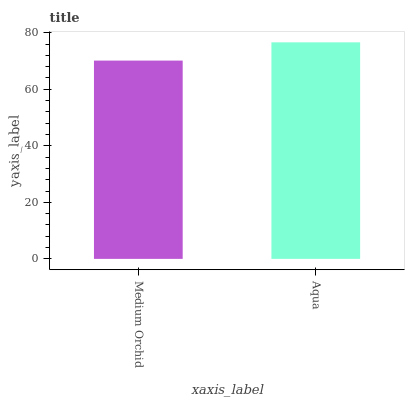Is Aqua the minimum?
Answer yes or no. No. Is Aqua greater than Medium Orchid?
Answer yes or no. Yes. Is Medium Orchid less than Aqua?
Answer yes or no. Yes. Is Medium Orchid greater than Aqua?
Answer yes or no. No. Is Aqua less than Medium Orchid?
Answer yes or no. No. Is Aqua the high median?
Answer yes or no. Yes. Is Medium Orchid the low median?
Answer yes or no. Yes. Is Medium Orchid the high median?
Answer yes or no. No. Is Aqua the low median?
Answer yes or no. No. 